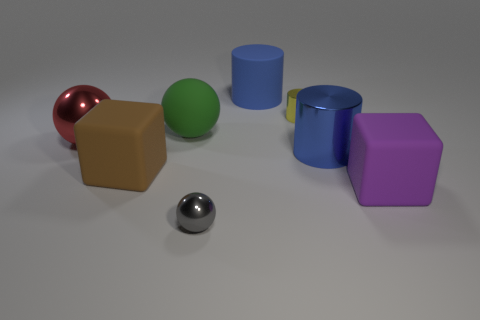What number of shiny objects are either yellow cylinders or large balls?
Your answer should be very brief. 2. There is a blue object behind the large blue cylinder that is in front of the large matte cylinder; are there any small cylinders to the right of it?
Offer a terse response. Yes. What size is the purple block that is the same material as the big green thing?
Offer a terse response. Large. Are there any rubber spheres in front of the small gray metal ball?
Offer a terse response. No. There is a rubber object behind the small cylinder; is there a large blue shiny cylinder that is to the left of it?
Your answer should be very brief. No. Does the metal sphere that is to the right of the large brown matte object have the same size as the matte cube that is on the left side of the green rubber object?
Offer a very short reply. No. How many tiny things are cyan balls or purple objects?
Your response must be concise. 0. There is a large blue thing on the left side of the large shiny thing on the right side of the gray sphere; what is it made of?
Give a very brief answer. Rubber. There is a thing that is the same color as the matte cylinder; what shape is it?
Make the answer very short. Cylinder. Is there a yellow cylinder made of the same material as the red sphere?
Ensure brevity in your answer.  Yes. 